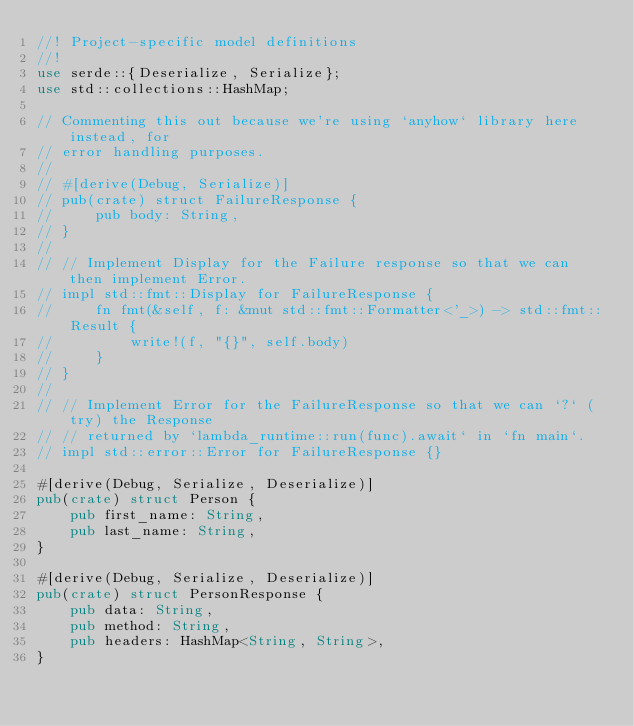<code> <loc_0><loc_0><loc_500><loc_500><_Rust_>//! Project-specific model definitions
//!
use serde::{Deserialize, Serialize};
use std::collections::HashMap;

// Commenting this out because we're using `anyhow` library here instead, for
// error handling purposes.
//
// #[derive(Debug, Serialize)]
// pub(crate) struct FailureResponse {
//     pub body: String,
// }
//
// // Implement Display for the Failure response so that we can then implement Error.
// impl std::fmt::Display for FailureResponse {
//     fn fmt(&self, f: &mut std::fmt::Formatter<'_>) -> std::fmt::Result {
//         write!(f, "{}", self.body)
//     }
// }
//
// // Implement Error for the FailureResponse so that we can `?` (try) the Response
// // returned by `lambda_runtime::run(func).await` in `fn main`.
// impl std::error::Error for FailureResponse {}

#[derive(Debug, Serialize, Deserialize)]
pub(crate) struct Person {
    pub first_name: String,
    pub last_name: String,
}

#[derive(Debug, Serialize, Deserialize)]
pub(crate) struct PersonResponse {
    pub data: String,
    pub method: String,
    pub headers: HashMap<String, String>,
}
</code> 